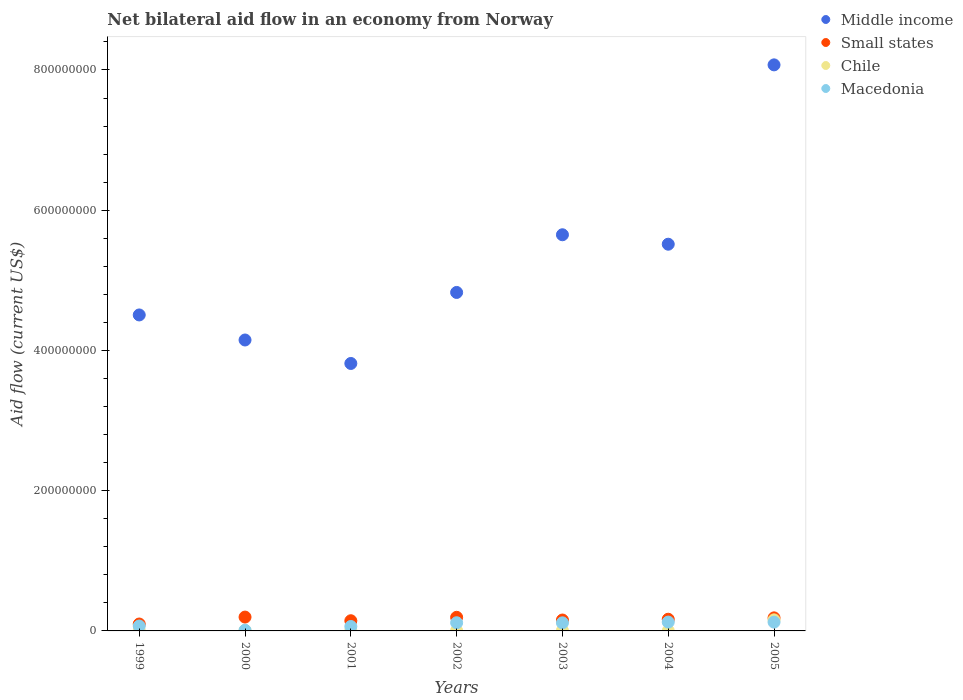Is the number of dotlines equal to the number of legend labels?
Keep it short and to the point. Yes. What is the net bilateral aid flow in Middle income in 2002?
Provide a succinct answer. 4.83e+08. Across all years, what is the maximum net bilateral aid flow in Small states?
Keep it short and to the point. 1.97e+07. Across all years, what is the minimum net bilateral aid flow in Chile?
Keep it short and to the point. 2.40e+05. In which year was the net bilateral aid flow in Middle income minimum?
Your answer should be compact. 2001. What is the total net bilateral aid flow in Small states in the graph?
Give a very brief answer. 1.14e+08. What is the difference between the net bilateral aid flow in Small states in 2000 and that in 2003?
Provide a succinct answer. 4.18e+06. What is the difference between the net bilateral aid flow in Middle income in 2004 and the net bilateral aid flow in Macedonia in 2002?
Provide a succinct answer. 5.40e+08. What is the average net bilateral aid flow in Chile per year?
Make the answer very short. 2.73e+06. In the year 2005, what is the difference between the net bilateral aid flow in Middle income and net bilateral aid flow in Small states?
Make the answer very short. 7.89e+08. In how many years, is the net bilateral aid flow in Middle income greater than 80000000 US$?
Provide a short and direct response. 7. What is the ratio of the net bilateral aid flow in Middle income in 2001 to that in 2005?
Make the answer very short. 0.47. Is the net bilateral aid flow in Middle income in 2004 less than that in 2005?
Offer a very short reply. Yes. What is the difference between the highest and the lowest net bilateral aid flow in Small states?
Give a very brief answer. 9.88e+06. In how many years, is the net bilateral aid flow in Small states greater than the average net bilateral aid flow in Small states taken over all years?
Make the answer very short. 4. Is it the case that in every year, the sum of the net bilateral aid flow in Chile and net bilateral aid flow in Small states  is greater than the sum of net bilateral aid flow in Middle income and net bilateral aid flow in Macedonia?
Your answer should be compact. No. Does the net bilateral aid flow in Middle income monotonically increase over the years?
Your answer should be very brief. No. What is the difference between two consecutive major ticks on the Y-axis?
Make the answer very short. 2.00e+08. Are the values on the major ticks of Y-axis written in scientific E-notation?
Provide a succinct answer. No. Does the graph contain any zero values?
Ensure brevity in your answer.  No. Where does the legend appear in the graph?
Offer a terse response. Top right. How many legend labels are there?
Your response must be concise. 4. How are the legend labels stacked?
Your answer should be compact. Vertical. What is the title of the graph?
Give a very brief answer. Net bilateral aid flow in an economy from Norway. Does "Greece" appear as one of the legend labels in the graph?
Give a very brief answer. No. What is the label or title of the X-axis?
Your answer should be compact. Years. What is the label or title of the Y-axis?
Your answer should be compact. Aid flow (current US$). What is the Aid flow (current US$) in Middle income in 1999?
Ensure brevity in your answer.  4.51e+08. What is the Aid flow (current US$) in Small states in 1999?
Offer a terse response. 9.85e+06. What is the Aid flow (current US$) of Macedonia in 1999?
Give a very brief answer. 6.99e+06. What is the Aid flow (current US$) of Middle income in 2000?
Provide a succinct answer. 4.15e+08. What is the Aid flow (current US$) in Small states in 2000?
Provide a short and direct response. 1.97e+07. What is the Aid flow (current US$) in Chile in 2000?
Make the answer very short. 6.50e+05. What is the Aid flow (current US$) of Macedonia in 2000?
Provide a succinct answer. 9.60e+05. What is the Aid flow (current US$) in Middle income in 2001?
Offer a very short reply. 3.81e+08. What is the Aid flow (current US$) in Small states in 2001?
Ensure brevity in your answer.  1.45e+07. What is the Aid flow (current US$) of Chile in 2001?
Keep it short and to the point. 7.60e+05. What is the Aid flow (current US$) of Macedonia in 2001?
Your answer should be very brief. 6.33e+06. What is the Aid flow (current US$) of Middle income in 2002?
Your response must be concise. 4.83e+08. What is the Aid flow (current US$) in Small states in 2002?
Make the answer very short. 1.94e+07. What is the Aid flow (current US$) in Macedonia in 2002?
Your response must be concise. 1.17e+07. What is the Aid flow (current US$) in Middle income in 2003?
Provide a succinct answer. 5.65e+08. What is the Aid flow (current US$) in Small states in 2003?
Offer a terse response. 1.56e+07. What is the Aid flow (current US$) in Chile in 2003?
Your answer should be compact. 6.40e+05. What is the Aid flow (current US$) in Macedonia in 2003?
Give a very brief answer. 1.15e+07. What is the Aid flow (current US$) of Middle income in 2004?
Your answer should be very brief. 5.52e+08. What is the Aid flow (current US$) of Small states in 2004?
Your response must be concise. 1.66e+07. What is the Aid flow (current US$) of Chile in 2004?
Provide a succinct answer. 2.40e+05. What is the Aid flow (current US$) in Macedonia in 2004?
Give a very brief answer. 1.26e+07. What is the Aid flow (current US$) of Middle income in 2005?
Your answer should be compact. 8.07e+08. What is the Aid flow (current US$) in Small states in 2005?
Offer a terse response. 1.86e+07. What is the Aid flow (current US$) of Chile in 2005?
Ensure brevity in your answer.  1.58e+07. What is the Aid flow (current US$) in Macedonia in 2005?
Give a very brief answer. 1.25e+07. Across all years, what is the maximum Aid flow (current US$) in Middle income?
Provide a short and direct response. 8.07e+08. Across all years, what is the maximum Aid flow (current US$) in Small states?
Provide a short and direct response. 1.97e+07. Across all years, what is the maximum Aid flow (current US$) of Chile?
Your response must be concise. 1.58e+07. Across all years, what is the maximum Aid flow (current US$) in Macedonia?
Your answer should be very brief. 1.26e+07. Across all years, what is the minimum Aid flow (current US$) of Middle income?
Your response must be concise. 3.81e+08. Across all years, what is the minimum Aid flow (current US$) of Small states?
Offer a very short reply. 9.85e+06. Across all years, what is the minimum Aid flow (current US$) in Macedonia?
Your answer should be compact. 9.60e+05. What is the total Aid flow (current US$) in Middle income in the graph?
Give a very brief answer. 3.65e+09. What is the total Aid flow (current US$) in Small states in the graph?
Your answer should be compact. 1.14e+08. What is the total Aid flow (current US$) in Chile in the graph?
Provide a short and direct response. 1.91e+07. What is the total Aid flow (current US$) in Macedonia in the graph?
Keep it short and to the point. 6.26e+07. What is the difference between the Aid flow (current US$) of Middle income in 1999 and that in 2000?
Offer a terse response. 3.57e+07. What is the difference between the Aid flow (current US$) in Small states in 1999 and that in 2000?
Provide a succinct answer. -9.88e+06. What is the difference between the Aid flow (current US$) of Macedonia in 1999 and that in 2000?
Offer a terse response. 6.03e+06. What is the difference between the Aid flow (current US$) of Middle income in 1999 and that in 2001?
Provide a succinct answer. 6.92e+07. What is the difference between the Aid flow (current US$) of Small states in 1999 and that in 2001?
Make the answer very short. -4.66e+06. What is the difference between the Aid flow (current US$) in Middle income in 1999 and that in 2002?
Offer a terse response. -3.21e+07. What is the difference between the Aid flow (current US$) of Small states in 1999 and that in 2002?
Offer a terse response. -9.55e+06. What is the difference between the Aid flow (current US$) of Macedonia in 1999 and that in 2002?
Keep it short and to the point. -4.67e+06. What is the difference between the Aid flow (current US$) in Middle income in 1999 and that in 2003?
Offer a very short reply. -1.14e+08. What is the difference between the Aid flow (current US$) in Small states in 1999 and that in 2003?
Offer a very short reply. -5.70e+06. What is the difference between the Aid flow (current US$) in Chile in 1999 and that in 2003?
Offer a terse response. -4.00e+04. What is the difference between the Aid flow (current US$) of Macedonia in 1999 and that in 2003?
Offer a terse response. -4.55e+06. What is the difference between the Aid flow (current US$) in Middle income in 1999 and that in 2004?
Your answer should be compact. -1.01e+08. What is the difference between the Aid flow (current US$) of Small states in 1999 and that in 2004?
Offer a terse response. -6.80e+06. What is the difference between the Aid flow (current US$) of Macedonia in 1999 and that in 2004?
Your response must be concise. -5.61e+06. What is the difference between the Aid flow (current US$) in Middle income in 1999 and that in 2005?
Your answer should be compact. -3.57e+08. What is the difference between the Aid flow (current US$) of Small states in 1999 and that in 2005?
Offer a terse response. -8.77e+06. What is the difference between the Aid flow (current US$) of Chile in 1999 and that in 2005?
Give a very brief answer. -1.52e+07. What is the difference between the Aid flow (current US$) of Macedonia in 1999 and that in 2005?
Your response must be concise. -5.55e+06. What is the difference between the Aid flow (current US$) in Middle income in 2000 and that in 2001?
Offer a very short reply. 3.35e+07. What is the difference between the Aid flow (current US$) of Small states in 2000 and that in 2001?
Offer a very short reply. 5.22e+06. What is the difference between the Aid flow (current US$) of Macedonia in 2000 and that in 2001?
Your answer should be compact. -5.37e+06. What is the difference between the Aid flow (current US$) in Middle income in 2000 and that in 2002?
Provide a succinct answer. -6.78e+07. What is the difference between the Aid flow (current US$) in Small states in 2000 and that in 2002?
Keep it short and to the point. 3.30e+05. What is the difference between the Aid flow (current US$) in Chile in 2000 and that in 2002?
Your response must be concise. 1.80e+05. What is the difference between the Aid flow (current US$) in Macedonia in 2000 and that in 2002?
Give a very brief answer. -1.07e+07. What is the difference between the Aid flow (current US$) in Middle income in 2000 and that in 2003?
Give a very brief answer. -1.50e+08. What is the difference between the Aid flow (current US$) in Small states in 2000 and that in 2003?
Make the answer very short. 4.18e+06. What is the difference between the Aid flow (current US$) of Chile in 2000 and that in 2003?
Your answer should be very brief. 10000. What is the difference between the Aid flow (current US$) in Macedonia in 2000 and that in 2003?
Provide a succinct answer. -1.06e+07. What is the difference between the Aid flow (current US$) in Middle income in 2000 and that in 2004?
Your answer should be compact. -1.37e+08. What is the difference between the Aid flow (current US$) of Small states in 2000 and that in 2004?
Your answer should be compact. 3.08e+06. What is the difference between the Aid flow (current US$) of Macedonia in 2000 and that in 2004?
Offer a very short reply. -1.16e+07. What is the difference between the Aid flow (current US$) of Middle income in 2000 and that in 2005?
Offer a terse response. -3.92e+08. What is the difference between the Aid flow (current US$) in Small states in 2000 and that in 2005?
Make the answer very short. 1.11e+06. What is the difference between the Aid flow (current US$) of Chile in 2000 and that in 2005?
Provide a succinct answer. -1.51e+07. What is the difference between the Aid flow (current US$) of Macedonia in 2000 and that in 2005?
Make the answer very short. -1.16e+07. What is the difference between the Aid flow (current US$) of Middle income in 2001 and that in 2002?
Your answer should be very brief. -1.01e+08. What is the difference between the Aid flow (current US$) of Small states in 2001 and that in 2002?
Offer a very short reply. -4.89e+06. What is the difference between the Aid flow (current US$) in Chile in 2001 and that in 2002?
Ensure brevity in your answer.  2.90e+05. What is the difference between the Aid flow (current US$) of Macedonia in 2001 and that in 2002?
Your response must be concise. -5.33e+06. What is the difference between the Aid flow (current US$) of Middle income in 2001 and that in 2003?
Make the answer very short. -1.84e+08. What is the difference between the Aid flow (current US$) of Small states in 2001 and that in 2003?
Make the answer very short. -1.04e+06. What is the difference between the Aid flow (current US$) in Chile in 2001 and that in 2003?
Provide a succinct answer. 1.20e+05. What is the difference between the Aid flow (current US$) of Macedonia in 2001 and that in 2003?
Make the answer very short. -5.21e+06. What is the difference between the Aid flow (current US$) of Middle income in 2001 and that in 2004?
Ensure brevity in your answer.  -1.70e+08. What is the difference between the Aid flow (current US$) of Small states in 2001 and that in 2004?
Your answer should be very brief. -2.14e+06. What is the difference between the Aid flow (current US$) of Chile in 2001 and that in 2004?
Give a very brief answer. 5.20e+05. What is the difference between the Aid flow (current US$) in Macedonia in 2001 and that in 2004?
Offer a very short reply. -6.27e+06. What is the difference between the Aid flow (current US$) in Middle income in 2001 and that in 2005?
Offer a terse response. -4.26e+08. What is the difference between the Aid flow (current US$) of Small states in 2001 and that in 2005?
Your response must be concise. -4.11e+06. What is the difference between the Aid flow (current US$) of Chile in 2001 and that in 2005?
Your answer should be very brief. -1.50e+07. What is the difference between the Aid flow (current US$) of Macedonia in 2001 and that in 2005?
Give a very brief answer. -6.21e+06. What is the difference between the Aid flow (current US$) of Middle income in 2002 and that in 2003?
Your answer should be very brief. -8.23e+07. What is the difference between the Aid flow (current US$) of Small states in 2002 and that in 2003?
Provide a short and direct response. 3.85e+06. What is the difference between the Aid flow (current US$) in Chile in 2002 and that in 2003?
Keep it short and to the point. -1.70e+05. What is the difference between the Aid flow (current US$) of Middle income in 2002 and that in 2004?
Provide a short and direct response. -6.88e+07. What is the difference between the Aid flow (current US$) in Small states in 2002 and that in 2004?
Provide a short and direct response. 2.75e+06. What is the difference between the Aid flow (current US$) of Chile in 2002 and that in 2004?
Provide a succinct answer. 2.30e+05. What is the difference between the Aid flow (current US$) in Macedonia in 2002 and that in 2004?
Offer a very short reply. -9.40e+05. What is the difference between the Aid flow (current US$) in Middle income in 2002 and that in 2005?
Provide a short and direct response. -3.25e+08. What is the difference between the Aid flow (current US$) in Small states in 2002 and that in 2005?
Give a very brief answer. 7.80e+05. What is the difference between the Aid flow (current US$) of Chile in 2002 and that in 2005?
Offer a very short reply. -1.53e+07. What is the difference between the Aid flow (current US$) in Macedonia in 2002 and that in 2005?
Keep it short and to the point. -8.80e+05. What is the difference between the Aid flow (current US$) in Middle income in 2003 and that in 2004?
Your response must be concise. 1.35e+07. What is the difference between the Aid flow (current US$) in Small states in 2003 and that in 2004?
Your answer should be compact. -1.10e+06. What is the difference between the Aid flow (current US$) of Chile in 2003 and that in 2004?
Your answer should be compact. 4.00e+05. What is the difference between the Aid flow (current US$) of Macedonia in 2003 and that in 2004?
Make the answer very short. -1.06e+06. What is the difference between the Aid flow (current US$) in Middle income in 2003 and that in 2005?
Offer a very short reply. -2.42e+08. What is the difference between the Aid flow (current US$) of Small states in 2003 and that in 2005?
Your answer should be compact. -3.07e+06. What is the difference between the Aid flow (current US$) in Chile in 2003 and that in 2005?
Your answer should be very brief. -1.51e+07. What is the difference between the Aid flow (current US$) in Middle income in 2004 and that in 2005?
Keep it short and to the point. -2.56e+08. What is the difference between the Aid flow (current US$) of Small states in 2004 and that in 2005?
Make the answer very short. -1.97e+06. What is the difference between the Aid flow (current US$) in Chile in 2004 and that in 2005?
Ensure brevity in your answer.  -1.55e+07. What is the difference between the Aid flow (current US$) of Macedonia in 2004 and that in 2005?
Ensure brevity in your answer.  6.00e+04. What is the difference between the Aid flow (current US$) in Middle income in 1999 and the Aid flow (current US$) in Small states in 2000?
Offer a very short reply. 4.31e+08. What is the difference between the Aid flow (current US$) in Middle income in 1999 and the Aid flow (current US$) in Chile in 2000?
Ensure brevity in your answer.  4.50e+08. What is the difference between the Aid flow (current US$) in Middle income in 1999 and the Aid flow (current US$) in Macedonia in 2000?
Offer a very short reply. 4.50e+08. What is the difference between the Aid flow (current US$) in Small states in 1999 and the Aid flow (current US$) in Chile in 2000?
Your response must be concise. 9.20e+06. What is the difference between the Aid flow (current US$) in Small states in 1999 and the Aid flow (current US$) in Macedonia in 2000?
Your response must be concise. 8.89e+06. What is the difference between the Aid flow (current US$) in Chile in 1999 and the Aid flow (current US$) in Macedonia in 2000?
Give a very brief answer. -3.60e+05. What is the difference between the Aid flow (current US$) in Middle income in 1999 and the Aid flow (current US$) in Small states in 2001?
Your answer should be very brief. 4.36e+08. What is the difference between the Aid flow (current US$) of Middle income in 1999 and the Aid flow (current US$) of Chile in 2001?
Provide a short and direct response. 4.50e+08. What is the difference between the Aid flow (current US$) of Middle income in 1999 and the Aid flow (current US$) of Macedonia in 2001?
Offer a very short reply. 4.44e+08. What is the difference between the Aid flow (current US$) of Small states in 1999 and the Aid flow (current US$) of Chile in 2001?
Give a very brief answer. 9.09e+06. What is the difference between the Aid flow (current US$) of Small states in 1999 and the Aid flow (current US$) of Macedonia in 2001?
Make the answer very short. 3.52e+06. What is the difference between the Aid flow (current US$) in Chile in 1999 and the Aid flow (current US$) in Macedonia in 2001?
Provide a succinct answer. -5.73e+06. What is the difference between the Aid flow (current US$) of Middle income in 1999 and the Aid flow (current US$) of Small states in 2002?
Provide a succinct answer. 4.31e+08. What is the difference between the Aid flow (current US$) of Middle income in 1999 and the Aid flow (current US$) of Chile in 2002?
Your answer should be very brief. 4.50e+08. What is the difference between the Aid flow (current US$) in Middle income in 1999 and the Aid flow (current US$) in Macedonia in 2002?
Your answer should be compact. 4.39e+08. What is the difference between the Aid flow (current US$) of Small states in 1999 and the Aid flow (current US$) of Chile in 2002?
Make the answer very short. 9.38e+06. What is the difference between the Aid flow (current US$) in Small states in 1999 and the Aid flow (current US$) in Macedonia in 2002?
Ensure brevity in your answer.  -1.81e+06. What is the difference between the Aid flow (current US$) in Chile in 1999 and the Aid flow (current US$) in Macedonia in 2002?
Your answer should be compact. -1.11e+07. What is the difference between the Aid flow (current US$) in Middle income in 1999 and the Aid flow (current US$) in Small states in 2003?
Keep it short and to the point. 4.35e+08. What is the difference between the Aid flow (current US$) of Middle income in 1999 and the Aid flow (current US$) of Chile in 2003?
Provide a short and direct response. 4.50e+08. What is the difference between the Aid flow (current US$) of Middle income in 1999 and the Aid flow (current US$) of Macedonia in 2003?
Ensure brevity in your answer.  4.39e+08. What is the difference between the Aid flow (current US$) of Small states in 1999 and the Aid flow (current US$) of Chile in 2003?
Give a very brief answer. 9.21e+06. What is the difference between the Aid flow (current US$) in Small states in 1999 and the Aid flow (current US$) in Macedonia in 2003?
Provide a succinct answer. -1.69e+06. What is the difference between the Aid flow (current US$) in Chile in 1999 and the Aid flow (current US$) in Macedonia in 2003?
Ensure brevity in your answer.  -1.09e+07. What is the difference between the Aid flow (current US$) of Middle income in 1999 and the Aid flow (current US$) of Small states in 2004?
Your answer should be very brief. 4.34e+08. What is the difference between the Aid flow (current US$) of Middle income in 1999 and the Aid flow (current US$) of Chile in 2004?
Provide a short and direct response. 4.50e+08. What is the difference between the Aid flow (current US$) of Middle income in 1999 and the Aid flow (current US$) of Macedonia in 2004?
Keep it short and to the point. 4.38e+08. What is the difference between the Aid flow (current US$) of Small states in 1999 and the Aid flow (current US$) of Chile in 2004?
Your answer should be compact. 9.61e+06. What is the difference between the Aid flow (current US$) in Small states in 1999 and the Aid flow (current US$) in Macedonia in 2004?
Provide a succinct answer. -2.75e+06. What is the difference between the Aid flow (current US$) in Chile in 1999 and the Aid flow (current US$) in Macedonia in 2004?
Your answer should be compact. -1.20e+07. What is the difference between the Aid flow (current US$) in Middle income in 1999 and the Aid flow (current US$) in Small states in 2005?
Offer a terse response. 4.32e+08. What is the difference between the Aid flow (current US$) in Middle income in 1999 and the Aid flow (current US$) in Chile in 2005?
Provide a short and direct response. 4.35e+08. What is the difference between the Aid flow (current US$) in Middle income in 1999 and the Aid flow (current US$) in Macedonia in 2005?
Provide a succinct answer. 4.38e+08. What is the difference between the Aid flow (current US$) of Small states in 1999 and the Aid flow (current US$) of Chile in 2005?
Provide a short and direct response. -5.93e+06. What is the difference between the Aid flow (current US$) of Small states in 1999 and the Aid flow (current US$) of Macedonia in 2005?
Offer a terse response. -2.69e+06. What is the difference between the Aid flow (current US$) of Chile in 1999 and the Aid flow (current US$) of Macedonia in 2005?
Your answer should be very brief. -1.19e+07. What is the difference between the Aid flow (current US$) of Middle income in 2000 and the Aid flow (current US$) of Small states in 2001?
Give a very brief answer. 4.00e+08. What is the difference between the Aid flow (current US$) of Middle income in 2000 and the Aid flow (current US$) of Chile in 2001?
Offer a terse response. 4.14e+08. What is the difference between the Aid flow (current US$) in Middle income in 2000 and the Aid flow (current US$) in Macedonia in 2001?
Keep it short and to the point. 4.09e+08. What is the difference between the Aid flow (current US$) in Small states in 2000 and the Aid flow (current US$) in Chile in 2001?
Provide a succinct answer. 1.90e+07. What is the difference between the Aid flow (current US$) of Small states in 2000 and the Aid flow (current US$) of Macedonia in 2001?
Provide a short and direct response. 1.34e+07. What is the difference between the Aid flow (current US$) in Chile in 2000 and the Aid flow (current US$) in Macedonia in 2001?
Provide a short and direct response. -5.68e+06. What is the difference between the Aid flow (current US$) of Middle income in 2000 and the Aid flow (current US$) of Small states in 2002?
Keep it short and to the point. 3.96e+08. What is the difference between the Aid flow (current US$) of Middle income in 2000 and the Aid flow (current US$) of Chile in 2002?
Give a very brief answer. 4.14e+08. What is the difference between the Aid flow (current US$) in Middle income in 2000 and the Aid flow (current US$) in Macedonia in 2002?
Keep it short and to the point. 4.03e+08. What is the difference between the Aid flow (current US$) of Small states in 2000 and the Aid flow (current US$) of Chile in 2002?
Your answer should be compact. 1.93e+07. What is the difference between the Aid flow (current US$) in Small states in 2000 and the Aid flow (current US$) in Macedonia in 2002?
Give a very brief answer. 8.07e+06. What is the difference between the Aid flow (current US$) in Chile in 2000 and the Aid flow (current US$) in Macedonia in 2002?
Provide a succinct answer. -1.10e+07. What is the difference between the Aid flow (current US$) in Middle income in 2000 and the Aid flow (current US$) in Small states in 2003?
Your answer should be compact. 3.99e+08. What is the difference between the Aid flow (current US$) in Middle income in 2000 and the Aid flow (current US$) in Chile in 2003?
Give a very brief answer. 4.14e+08. What is the difference between the Aid flow (current US$) in Middle income in 2000 and the Aid flow (current US$) in Macedonia in 2003?
Provide a short and direct response. 4.03e+08. What is the difference between the Aid flow (current US$) in Small states in 2000 and the Aid flow (current US$) in Chile in 2003?
Make the answer very short. 1.91e+07. What is the difference between the Aid flow (current US$) of Small states in 2000 and the Aid flow (current US$) of Macedonia in 2003?
Keep it short and to the point. 8.19e+06. What is the difference between the Aid flow (current US$) in Chile in 2000 and the Aid flow (current US$) in Macedonia in 2003?
Offer a terse response. -1.09e+07. What is the difference between the Aid flow (current US$) in Middle income in 2000 and the Aid flow (current US$) in Small states in 2004?
Keep it short and to the point. 3.98e+08. What is the difference between the Aid flow (current US$) in Middle income in 2000 and the Aid flow (current US$) in Chile in 2004?
Make the answer very short. 4.15e+08. What is the difference between the Aid flow (current US$) in Middle income in 2000 and the Aid flow (current US$) in Macedonia in 2004?
Offer a terse response. 4.02e+08. What is the difference between the Aid flow (current US$) of Small states in 2000 and the Aid flow (current US$) of Chile in 2004?
Make the answer very short. 1.95e+07. What is the difference between the Aid flow (current US$) in Small states in 2000 and the Aid flow (current US$) in Macedonia in 2004?
Provide a succinct answer. 7.13e+06. What is the difference between the Aid flow (current US$) of Chile in 2000 and the Aid flow (current US$) of Macedonia in 2004?
Offer a very short reply. -1.20e+07. What is the difference between the Aid flow (current US$) in Middle income in 2000 and the Aid flow (current US$) in Small states in 2005?
Give a very brief answer. 3.96e+08. What is the difference between the Aid flow (current US$) in Middle income in 2000 and the Aid flow (current US$) in Chile in 2005?
Your answer should be very brief. 3.99e+08. What is the difference between the Aid flow (current US$) of Middle income in 2000 and the Aid flow (current US$) of Macedonia in 2005?
Make the answer very short. 4.02e+08. What is the difference between the Aid flow (current US$) of Small states in 2000 and the Aid flow (current US$) of Chile in 2005?
Make the answer very short. 3.95e+06. What is the difference between the Aid flow (current US$) in Small states in 2000 and the Aid flow (current US$) in Macedonia in 2005?
Your answer should be compact. 7.19e+06. What is the difference between the Aid flow (current US$) of Chile in 2000 and the Aid flow (current US$) of Macedonia in 2005?
Your answer should be very brief. -1.19e+07. What is the difference between the Aid flow (current US$) of Middle income in 2001 and the Aid flow (current US$) of Small states in 2002?
Make the answer very short. 3.62e+08. What is the difference between the Aid flow (current US$) in Middle income in 2001 and the Aid flow (current US$) in Chile in 2002?
Offer a terse response. 3.81e+08. What is the difference between the Aid flow (current US$) in Middle income in 2001 and the Aid flow (current US$) in Macedonia in 2002?
Your answer should be compact. 3.70e+08. What is the difference between the Aid flow (current US$) of Small states in 2001 and the Aid flow (current US$) of Chile in 2002?
Give a very brief answer. 1.40e+07. What is the difference between the Aid flow (current US$) of Small states in 2001 and the Aid flow (current US$) of Macedonia in 2002?
Provide a short and direct response. 2.85e+06. What is the difference between the Aid flow (current US$) in Chile in 2001 and the Aid flow (current US$) in Macedonia in 2002?
Offer a terse response. -1.09e+07. What is the difference between the Aid flow (current US$) of Middle income in 2001 and the Aid flow (current US$) of Small states in 2003?
Offer a very short reply. 3.66e+08. What is the difference between the Aid flow (current US$) of Middle income in 2001 and the Aid flow (current US$) of Chile in 2003?
Provide a short and direct response. 3.81e+08. What is the difference between the Aid flow (current US$) in Middle income in 2001 and the Aid flow (current US$) in Macedonia in 2003?
Make the answer very short. 3.70e+08. What is the difference between the Aid flow (current US$) of Small states in 2001 and the Aid flow (current US$) of Chile in 2003?
Your answer should be very brief. 1.39e+07. What is the difference between the Aid flow (current US$) of Small states in 2001 and the Aid flow (current US$) of Macedonia in 2003?
Your answer should be very brief. 2.97e+06. What is the difference between the Aid flow (current US$) in Chile in 2001 and the Aid flow (current US$) in Macedonia in 2003?
Give a very brief answer. -1.08e+07. What is the difference between the Aid flow (current US$) of Middle income in 2001 and the Aid flow (current US$) of Small states in 2004?
Your response must be concise. 3.65e+08. What is the difference between the Aid flow (current US$) in Middle income in 2001 and the Aid flow (current US$) in Chile in 2004?
Your answer should be very brief. 3.81e+08. What is the difference between the Aid flow (current US$) in Middle income in 2001 and the Aid flow (current US$) in Macedonia in 2004?
Make the answer very short. 3.69e+08. What is the difference between the Aid flow (current US$) of Small states in 2001 and the Aid flow (current US$) of Chile in 2004?
Make the answer very short. 1.43e+07. What is the difference between the Aid flow (current US$) in Small states in 2001 and the Aid flow (current US$) in Macedonia in 2004?
Provide a succinct answer. 1.91e+06. What is the difference between the Aid flow (current US$) of Chile in 2001 and the Aid flow (current US$) of Macedonia in 2004?
Your response must be concise. -1.18e+07. What is the difference between the Aid flow (current US$) in Middle income in 2001 and the Aid flow (current US$) in Small states in 2005?
Your answer should be very brief. 3.63e+08. What is the difference between the Aid flow (current US$) in Middle income in 2001 and the Aid flow (current US$) in Chile in 2005?
Make the answer very short. 3.66e+08. What is the difference between the Aid flow (current US$) of Middle income in 2001 and the Aid flow (current US$) of Macedonia in 2005?
Ensure brevity in your answer.  3.69e+08. What is the difference between the Aid flow (current US$) in Small states in 2001 and the Aid flow (current US$) in Chile in 2005?
Offer a terse response. -1.27e+06. What is the difference between the Aid flow (current US$) of Small states in 2001 and the Aid flow (current US$) of Macedonia in 2005?
Make the answer very short. 1.97e+06. What is the difference between the Aid flow (current US$) of Chile in 2001 and the Aid flow (current US$) of Macedonia in 2005?
Ensure brevity in your answer.  -1.18e+07. What is the difference between the Aid flow (current US$) in Middle income in 2002 and the Aid flow (current US$) in Small states in 2003?
Offer a very short reply. 4.67e+08. What is the difference between the Aid flow (current US$) in Middle income in 2002 and the Aid flow (current US$) in Chile in 2003?
Provide a succinct answer. 4.82e+08. What is the difference between the Aid flow (current US$) in Middle income in 2002 and the Aid flow (current US$) in Macedonia in 2003?
Your response must be concise. 4.71e+08. What is the difference between the Aid flow (current US$) in Small states in 2002 and the Aid flow (current US$) in Chile in 2003?
Keep it short and to the point. 1.88e+07. What is the difference between the Aid flow (current US$) in Small states in 2002 and the Aid flow (current US$) in Macedonia in 2003?
Offer a terse response. 7.86e+06. What is the difference between the Aid flow (current US$) of Chile in 2002 and the Aid flow (current US$) of Macedonia in 2003?
Make the answer very short. -1.11e+07. What is the difference between the Aid flow (current US$) in Middle income in 2002 and the Aid flow (current US$) in Small states in 2004?
Your answer should be very brief. 4.66e+08. What is the difference between the Aid flow (current US$) of Middle income in 2002 and the Aid flow (current US$) of Chile in 2004?
Make the answer very short. 4.82e+08. What is the difference between the Aid flow (current US$) of Middle income in 2002 and the Aid flow (current US$) of Macedonia in 2004?
Offer a terse response. 4.70e+08. What is the difference between the Aid flow (current US$) of Small states in 2002 and the Aid flow (current US$) of Chile in 2004?
Make the answer very short. 1.92e+07. What is the difference between the Aid flow (current US$) of Small states in 2002 and the Aid flow (current US$) of Macedonia in 2004?
Give a very brief answer. 6.80e+06. What is the difference between the Aid flow (current US$) of Chile in 2002 and the Aid flow (current US$) of Macedonia in 2004?
Your answer should be very brief. -1.21e+07. What is the difference between the Aid flow (current US$) in Middle income in 2002 and the Aid flow (current US$) in Small states in 2005?
Offer a very short reply. 4.64e+08. What is the difference between the Aid flow (current US$) in Middle income in 2002 and the Aid flow (current US$) in Chile in 2005?
Provide a succinct answer. 4.67e+08. What is the difference between the Aid flow (current US$) in Middle income in 2002 and the Aid flow (current US$) in Macedonia in 2005?
Keep it short and to the point. 4.70e+08. What is the difference between the Aid flow (current US$) in Small states in 2002 and the Aid flow (current US$) in Chile in 2005?
Provide a short and direct response. 3.62e+06. What is the difference between the Aid flow (current US$) in Small states in 2002 and the Aid flow (current US$) in Macedonia in 2005?
Make the answer very short. 6.86e+06. What is the difference between the Aid flow (current US$) of Chile in 2002 and the Aid flow (current US$) of Macedonia in 2005?
Keep it short and to the point. -1.21e+07. What is the difference between the Aid flow (current US$) in Middle income in 2003 and the Aid flow (current US$) in Small states in 2004?
Make the answer very short. 5.48e+08. What is the difference between the Aid flow (current US$) of Middle income in 2003 and the Aid flow (current US$) of Chile in 2004?
Ensure brevity in your answer.  5.65e+08. What is the difference between the Aid flow (current US$) of Middle income in 2003 and the Aid flow (current US$) of Macedonia in 2004?
Your response must be concise. 5.52e+08. What is the difference between the Aid flow (current US$) of Small states in 2003 and the Aid flow (current US$) of Chile in 2004?
Your answer should be very brief. 1.53e+07. What is the difference between the Aid flow (current US$) in Small states in 2003 and the Aid flow (current US$) in Macedonia in 2004?
Ensure brevity in your answer.  2.95e+06. What is the difference between the Aid flow (current US$) of Chile in 2003 and the Aid flow (current US$) of Macedonia in 2004?
Give a very brief answer. -1.20e+07. What is the difference between the Aid flow (current US$) in Middle income in 2003 and the Aid flow (current US$) in Small states in 2005?
Keep it short and to the point. 5.46e+08. What is the difference between the Aid flow (current US$) of Middle income in 2003 and the Aid flow (current US$) of Chile in 2005?
Provide a short and direct response. 5.49e+08. What is the difference between the Aid flow (current US$) of Middle income in 2003 and the Aid flow (current US$) of Macedonia in 2005?
Keep it short and to the point. 5.52e+08. What is the difference between the Aid flow (current US$) of Small states in 2003 and the Aid flow (current US$) of Macedonia in 2005?
Make the answer very short. 3.01e+06. What is the difference between the Aid flow (current US$) of Chile in 2003 and the Aid flow (current US$) of Macedonia in 2005?
Your answer should be compact. -1.19e+07. What is the difference between the Aid flow (current US$) of Middle income in 2004 and the Aid flow (current US$) of Small states in 2005?
Keep it short and to the point. 5.33e+08. What is the difference between the Aid flow (current US$) of Middle income in 2004 and the Aid flow (current US$) of Chile in 2005?
Offer a terse response. 5.36e+08. What is the difference between the Aid flow (current US$) of Middle income in 2004 and the Aid flow (current US$) of Macedonia in 2005?
Your response must be concise. 5.39e+08. What is the difference between the Aid flow (current US$) of Small states in 2004 and the Aid flow (current US$) of Chile in 2005?
Offer a very short reply. 8.70e+05. What is the difference between the Aid flow (current US$) of Small states in 2004 and the Aid flow (current US$) of Macedonia in 2005?
Offer a very short reply. 4.11e+06. What is the difference between the Aid flow (current US$) in Chile in 2004 and the Aid flow (current US$) in Macedonia in 2005?
Your answer should be very brief. -1.23e+07. What is the average Aid flow (current US$) of Middle income per year?
Provide a succinct answer. 5.22e+08. What is the average Aid flow (current US$) in Small states per year?
Make the answer very short. 1.63e+07. What is the average Aid flow (current US$) of Chile per year?
Provide a succinct answer. 2.73e+06. What is the average Aid flow (current US$) of Macedonia per year?
Offer a terse response. 8.95e+06. In the year 1999, what is the difference between the Aid flow (current US$) of Middle income and Aid flow (current US$) of Small states?
Provide a succinct answer. 4.41e+08. In the year 1999, what is the difference between the Aid flow (current US$) of Middle income and Aid flow (current US$) of Chile?
Keep it short and to the point. 4.50e+08. In the year 1999, what is the difference between the Aid flow (current US$) in Middle income and Aid flow (current US$) in Macedonia?
Offer a terse response. 4.44e+08. In the year 1999, what is the difference between the Aid flow (current US$) of Small states and Aid flow (current US$) of Chile?
Offer a terse response. 9.25e+06. In the year 1999, what is the difference between the Aid flow (current US$) in Small states and Aid flow (current US$) in Macedonia?
Provide a short and direct response. 2.86e+06. In the year 1999, what is the difference between the Aid flow (current US$) in Chile and Aid flow (current US$) in Macedonia?
Your answer should be very brief. -6.39e+06. In the year 2000, what is the difference between the Aid flow (current US$) in Middle income and Aid flow (current US$) in Small states?
Keep it short and to the point. 3.95e+08. In the year 2000, what is the difference between the Aid flow (current US$) of Middle income and Aid flow (current US$) of Chile?
Your answer should be very brief. 4.14e+08. In the year 2000, what is the difference between the Aid flow (current US$) of Middle income and Aid flow (current US$) of Macedonia?
Make the answer very short. 4.14e+08. In the year 2000, what is the difference between the Aid flow (current US$) in Small states and Aid flow (current US$) in Chile?
Offer a terse response. 1.91e+07. In the year 2000, what is the difference between the Aid flow (current US$) of Small states and Aid flow (current US$) of Macedonia?
Offer a very short reply. 1.88e+07. In the year 2000, what is the difference between the Aid flow (current US$) in Chile and Aid flow (current US$) in Macedonia?
Keep it short and to the point. -3.10e+05. In the year 2001, what is the difference between the Aid flow (current US$) of Middle income and Aid flow (current US$) of Small states?
Keep it short and to the point. 3.67e+08. In the year 2001, what is the difference between the Aid flow (current US$) of Middle income and Aid flow (current US$) of Chile?
Make the answer very short. 3.81e+08. In the year 2001, what is the difference between the Aid flow (current US$) of Middle income and Aid flow (current US$) of Macedonia?
Ensure brevity in your answer.  3.75e+08. In the year 2001, what is the difference between the Aid flow (current US$) in Small states and Aid flow (current US$) in Chile?
Your answer should be compact. 1.38e+07. In the year 2001, what is the difference between the Aid flow (current US$) in Small states and Aid flow (current US$) in Macedonia?
Your response must be concise. 8.18e+06. In the year 2001, what is the difference between the Aid flow (current US$) of Chile and Aid flow (current US$) of Macedonia?
Give a very brief answer. -5.57e+06. In the year 2002, what is the difference between the Aid flow (current US$) of Middle income and Aid flow (current US$) of Small states?
Provide a short and direct response. 4.63e+08. In the year 2002, what is the difference between the Aid flow (current US$) in Middle income and Aid flow (current US$) in Chile?
Provide a succinct answer. 4.82e+08. In the year 2002, what is the difference between the Aid flow (current US$) of Middle income and Aid flow (current US$) of Macedonia?
Ensure brevity in your answer.  4.71e+08. In the year 2002, what is the difference between the Aid flow (current US$) of Small states and Aid flow (current US$) of Chile?
Offer a terse response. 1.89e+07. In the year 2002, what is the difference between the Aid flow (current US$) in Small states and Aid flow (current US$) in Macedonia?
Your response must be concise. 7.74e+06. In the year 2002, what is the difference between the Aid flow (current US$) in Chile and Aid flow (current US$) in Macedonia?
Offer a very short reply. -1.12e+07. In the year 2003, what is the difference between the Aid flow (current US$) in Middle income and Aid flow (current US$) in Small states?
Your answer should be compact. 5.49e+08. In the year 2003, what is the difference between the Aid flow (current US$) in Middle income and Aid flow (current US$) in Chile?
Ensure brevity in your answer.  5.64e+08. In the year 2003, what is the difference between the Aid flow (current US$) in Middle income and Aid flow (current US$) in Macedonia?
Your answer should be compact. 5.53e+08. In the year 2003, what is the difference between the Aid flow (current US$) in Small states and Aid flow (current US$) in Chile?
Your answer should be compact. 1.49e+07. In the year 2003, what is the difference between the Aid flow (current US$) in Small states and Aid flow (current US$) in Macedonia?
Your answer should be compact. 4.01e+06. In the year 2003, what is the difference between the Aid flow (current US$) of Chile and Aid flow (current US$) of Macedonia?
Ensure brevity in your answer.  -1.09e+07. In the year 2004, what is the difference between the Aid flow (current US$) in Middle income and Aid flow (current US$) in Small states?
Make the answer very short. 5.35e+08. In the year 2004, what is the difference between the Aid flow (current US$) of Middle income and Aid flow (current US$) of Chile?
Keep it short and to the point. 5.51e+08. In the year 2004, what is the difference between the Aid flow (current US$) of Middle income and Aid flow (current US$) of Macedonia?
Offer a very short reply. 5.39e+08. In the year 2004, what is the difference between the Aid flow (current US$) of Small states and Aid flow (current US$) of Chile?
Your answer should be compact. 1.64e+07. In the year 2004, what is the difference between the Aid flow (current US$) of Small states and Aid flow (current US$) of Macedonia?
Ensure brevity in your answer.  4.05e+06. In the year 2004, what is the difference between the Aid flow (current US$) of Chile and Aid flow (current US$) of Macedonia?
Your answer should be compact. -1.24e+07. In the year 2005, what is the difference between the Aid flow (current US$) of Middle income and Aid flow (current US$) of Small states?
Offer a very short reply. 7.89e+08. In the year 2005, what is the difference between the Aid flow (current US$) in Middle income and Aid flow (current US$) in Chile?
Offer a very short reply. 7.91e+08. In the year 2005, what is the difference between the Aid flow (current US$) of Middle income and Aid flow (current US$) of Macedonia?
Keep it short and to the point. 7.95e+08. In the year 2005, what is the difference between the Aid flow (current US$) in Small states and Aid flow (current US$) in Chile?
Give a very brief answer. 2.84e+06. In the year 2005, what is the difference between the Aid flow (current US$) of Small states and Aid flow (current US$) of Macedonia?
Provide a succinct answer. 6.08e+06. In the year 2005, what is the difference between the Aid flow (current US$) of Chile and Aid flow (current US$) of Macedonia?
Offer a very short reply. 3.24e+06. What is the ratio of the Aid flow (current US$) in Middle income in 1999 to that in 2000?
Keep it short and to the point. 1.09. What is the ratio of the Aid flow (current US$) in Small states in 1999 to that in 2000?
Your response must be concise. 0.5. What is the ratio of the Aid flow (current US$) of Macedonia in 1999 to that in 2000?
Your answer should be very brief. 7.28. What is the ratio of the Aid flow (current US$) in Middle income in 1999 to that in 2001?
Your response must be concise. 1.18. What is the ratio of the Aid flow (current US$) of Small states in 1999 to that in 2001?
Give a very brief answer. 0.68. What is the ratio of the Aid flow (current US$) in Chile in 1999 to that in 2001?
Your response must be concise. 0.79. What is the ratio of the Aid flow (current US$) in Macedonia in 1999 to that in 2001?
Offer a very short reply. 1.1. What is the ratio of the Aid flow (current US$) of Middle income in 1999 to that in 2002?
Your response must be concise. 0.93. What is the ratio of the Aid flow (current US$) in Small states in 1999 to that in 2002?
Provide a short and direct response. 0.51. What is the ratio of the Aid flow (current US$) of Chile in 1999 to that in 2002?
Keep it short and to the point. 1.28. What is the ratio of the Aid flow (current US$) in Macedonia in 1999 to that in 2002?
Offer a terse response. 0.6. What is the ratio of the Aid flow (current US$) of Middle income in 1999 to that in 2003?
Your answer should be compact. 0.8. What is the ratio of the Aid flow (current US$) of Small states in 1999 to that in 2003?
Give a very brief answer. 0.63. What is the ratio of the Aid flow (current US$) of Chile in 1999 to that in 2003?
Provide a succinct answer. 0.94. What is the ratio of the Aid flow (current US$) of Macedonia in 1999 to that in 2003?
Give a very brief answer. 0.61. What is the ratio of the Aid flow (current US$) in Middle income in 1999 to that in 2004?
Keep it short and to the point. 0.82. What is the ratio of the Aid flow (current US$) of Small states in 1999 to that in 2004?
Keep it short and to the point. 0.59. What is the ratio of the Aid flow (current US$) of Macedonia in 1999 to that in 2004?
Offer a terse response. 0.55. What is the ratio of the Aid flow (current US$) of Middle income in 1999 to that in 2005?
Your answer should be compact. 0.56. What is the ratio of the Aid flow (current US$) in Small states in 1999 to that in 2005?
Your response must be concise. 0.53. What is the ratio of the Aid flow (current US$) of Chile in 1999 to that in 2005?
Make the answer very short. 0.04. What is the ratio of the Aid flow (current US$) of Macedonia in 1999 to that in 2005?
Provide a short and direct response. 0.56. What is the ratio of the Aid flow (current US$) in Middle income in 2000 to that in 2001?
Give a very brief answer. 1.09. What is the ratio of the Aid flow (current US$) of Small states in 2000 to that in 2001?
Keep it short and to the point. 1.36. What is the ratio of the Aid flow (current US$) of Chile in 2000 to that in 2001?
Ensure brevity in your answer.  0.86. What is the ratio of the Aid flow (current US$) in Macedonia in 2000 to that in 2001?
Ensure brevity in your answer.  0.15. What is the ratio of the Aid flow (current US$) in Middle income in 2000 to that in 2002?
Your answer should be very brief. 0.86. What is the ratio of the Aid flow (current US$) of Chile in 2000 to that in 2002?
Make the answer very short. 1.38. What is the ratio of the Aid flow (current US$) of Macedonia in 2000 to that in 2002?
Offer a terse response. 0.08. What is the ratio of the Aid flow (current US$) of Middle income in 2000 to that in 2003?
Make the answer very short. 0.73. What is the ratio of the Aid flow (current US$) in Small states in 2000 to that in 2003?
Your response must be concise. 1.27. What is the ratio of the Aid flow (current US$) of Chile in 2000 to that in 2003?
Provide a short and direct response. 1.02. What is the ratio of the Aid flow (current US$) in Macedonia in 2000 to that in 2003?
Give a very brief answer. 0.08. What is the ratio of the Aid flow (current US$) of Middle income in 2000 to that in 2004?
Your answer should be compact. 0.75. What is the ratio of the Aid flow (current US$) of Small states in 2000 to that in 2004?
Ensure brevity in your answer.  1.19. What is the ratio of the Aid flow (current US$) of Chile in 2000 to that in 2004?
Offer a very short reply. 2.71. What is the ratio of the Aid flow (current US$) in Macedonia in 2000 to that in 2004?
Your answer should be compact. 0.08. What is the ratio of the Aid flow (current US$) of Middle income in 2000 to that in 2005?
Make the answer very short. 0.51. What is the ratio of the Aid flow (current US$) in Small states in 2000 to that in 2005?
Offer a very short reply. 1.06. What is the ratio of the Aid flow (current US$) in Chile in 2000 to that in 2005?
Make the answer very short. 0.04. What is the ratio of the Aid flow (current US$) of Macedonia in 2000 to that in 2005?
Ensure brevity in your answer.  0.08. What is the ratio of the Aid flow (current US$) in Middle income in 2001 to that in 2002?
Provide a succinct answer. 0.79. What is the ratio of the Aid flow (current US$) in Small states in 2001 to that in 2002?
Your answer should be compact. 0.75. What is the ratio of the Aid flow (current US$) in Chile in 2001 to that in 2002?
Provide a succinct answer. 1.62. What is the ratio of the Aid flow (current US$) of Macedonia in 2001 to that in 2002?
Keep it short and to the point. 0.54. What is the ratio of the Aid flow (current US$) of Middle income in 2001 to that in 2003?
Provide a succinct answer. 0.68. What is the ratio of the Aid flow (current US$) in Small states in 2001 to that in 2003?
Offer a very short reply. 0.93. What is the ratio of the Aid flow (current US$) of Chile in 2001 to that in 2003?
Make the answer very short. 1.19. What is the ratio of the Aid flow (current US$) in Macedonia in 2001 to that in 2003?
Offer a very short reply. 0.55. What is the ratio of the Aid flow (current US$) of Middle income in 2001 to that in 2004?
Ensure brevity in your answer.  0.69. What is the ratio of the Aid flow (current US$) in Small states in 2001 to that in 2004?
Keep it short and to the point. 0.87. What is the ratio of the Aid flow (current US$) of Chile in 2001 to that in 2004?
Give a very brief answer. 3.17. What is the ratio of the Aid flow (current US$) of Macedonia in 2001 to that in 2004?
Offer a terse response. 0.5. What is the ratio of the Aid flow (current US$) of Middle income in 2001 to that in 2005?
Provide a succinct answer. 0.47. What is the ratio of the Aid flow (current US$) in Small states in 2001 to that in 2005?
Your answer should be very brief. 0.78. What is the ratio of the Aid flow (current US$) of Chile in 2001 to that in 2005?
Offer a terse response. 0.05. What is the ratio of the Aid flow (current US$) in Macedonia in 2001 to that in 2005?
Keep it short and to the point. 0.5. What is the ratio of the Aid flow (current US$) in Middle income in 2002 to that in 2003?
Offer a terse response. 0.85. What is the ratio of the Aid flow (current US$) of Small states in 2002 to that in 2003?
Ensure brevity in your answer.  1.25. What is the ratio of the Aid flow (current US$) in Chile in 2002 to that in 2003?
Ensure brevity in your answer.  0.73. What is the ratio of the Aid flow (current US$) of Macedonia in 2002 to that in 2003?
Keep it short and to the point. 1.01. What is the ratio of the Aid flow (current US$) of Middle income in 2002 to that in 2004?
Your answer should be very brief. 0.88. What is the ratio of the Aid flow (current US$) in Small states in 2002 to that in 2004?
Offer a terse response. 1.17. What is the ratio of the Aid flow (current US$) of Chile in 2002 to that in 2004?
Offer a very short reply. 1.96. What is the ratio of the Aid flow (current US$) of Macedonia in 2002 to that in 2004?
Ensure brevity in your answer.  0.93. What is the ratio of the Aid flow (current US$) of Middle income in 2002 to that in 2005?
Offer a terse response. 0.6. What is the ratio of the Aid flow (current US$) in Small states in 2002 to that in 2005?
Keep it short and to the point. 1.04. What is the ratio of the Aid flow (current US$) of Chile in 2002 to that in 2005?
Provide a short and direct response. 0.03. What is the ratio of the Aid flow (current US$) of Macedonia in 2002 to that in 2005?
Provide a short and direct response. 0.93. What is the ratio of the Aid flow (current US$) in Middle income in 2003 to that in 2004?
Offer a terse response. 1.02. What is the ratio of the Aid flow (current US$) in Small states in 2003 to that in 2004?
Ensure brevity in your answer.  0.93. What is the ratio of the Aid flow (current US$) of Chile in 2003 to that in 2004?
Give a very brief answer. 2.67. What is the ratio of the Aid flow (current US$) of Macedonia in 2003 to that in 2004?
Your answer should be compact. 0.92. What is the ratio of the Aid flow (current US$) in Middle income in 2003 to that in 2005?
Your answer should be very brief. 0.7. What is the ratio of the Aid flow (current US$) in Small states in 2003 to that in 2005?
Make the answer very short. 0.84. What is the ratio of the Aid flow (current US$) in Chile in 2003 to that in 2005?
Give a very brief answer. 0.04. What is the ratio of the Aid flow (current US$) in Macedonia in 2003 to that in 2005?
Offer a terse response. 0.92. What is the ratio of the Aid flow (current US$) in Middle income in 2004 to that in 2005?
Provide a succinct answer. 0.68. What is the ratio of the Aid flow (current US$) in Small states in 2004 to that in 2005?
Your answer should be compact. 0.89. What is the ratio of the Aid flow (current US$) of Chile in 2004 to that in 2005?
Offer a terse response. 0.02. What is the ratio of the Aid flow (current US$) in Macedonia in 2004 to that in 2005?
Provide a short and direct response. 1. What is the difference between the highest and the second highest Aid flow (current US$) in Middle income?
Your response must be concise. 2.42e+08. What is the difference between the highest and the second highest Aid flow (current US$) of Small states?
Your response must be concise. 3.30e+05. What is the difference between the highest and the second highest Aid flow (current US$) of Chile?
Your response must be concise. 1.50e+07. What is the difference between the highest and the second highest Aid flow (current US$) in Macedonia?
Offer a terse response. 6.00e+04. What is the difference between the highest and the lowest Aid flow (current US$) of Middle income?
Ensure brevity in your answer.  4.26e+08. What is the difference between the highest and the lowest Aid flow (current US$) in Small states?
Your answer should be compact. 9.88e+06. What is the difference between the highest and the lowest Aid flow (current US$) in Chile?
Provide a succinct answer. 1.55e+07. What is the difference between the highest and the lowest Aid flow (current US$) in Macedonia?
Ensure brevity in your answer.  1.16e+07. 